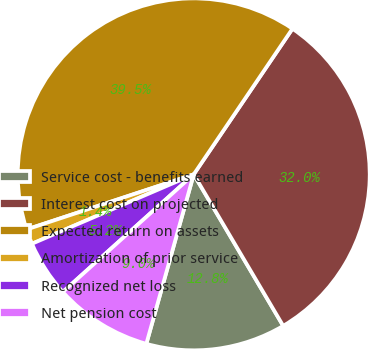Convert chart. <chart><loc_0><loc_0><loc_500><loc_500><pie_chart><fcel>Service cost - benefits earned<fcel>Interest cost on projected<fcel>Expected return on assets<fcel>Amortization of prior service<fcel>Recognized net loss<fcel>Net pension cost<nl><fcel>12.83%<fcel>32.03%<fcel>39.55%<fcel>1.38%<fcel>5.2%<fcel>9.01%<nl></chart> 